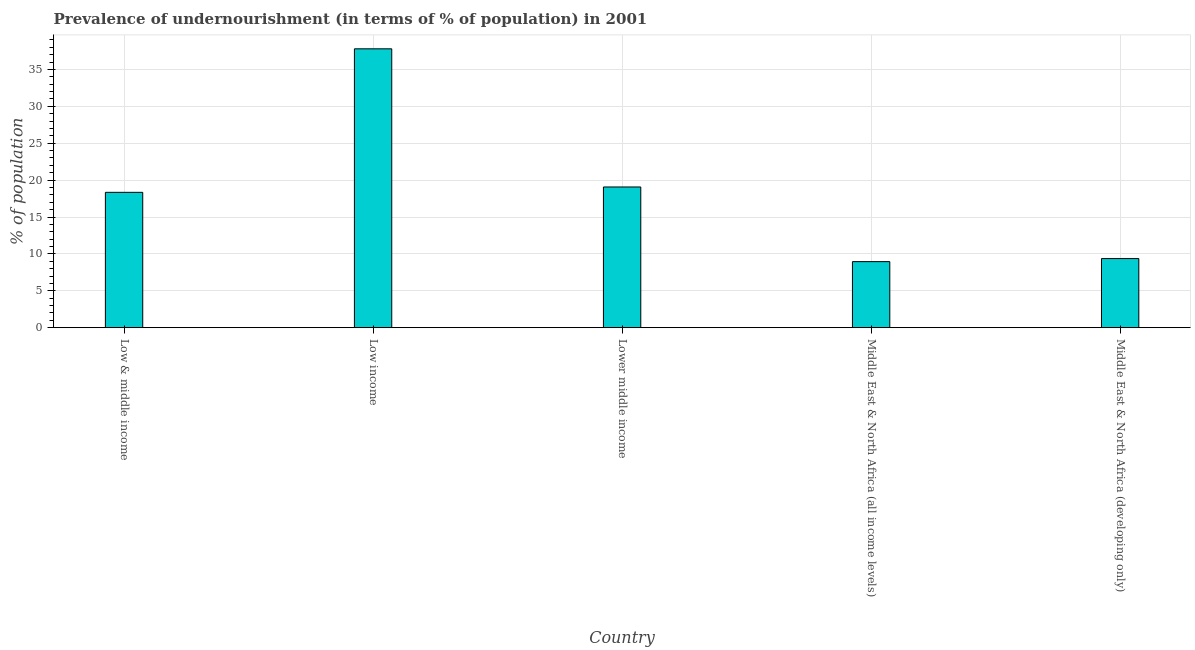Does the graph contain grids?
Provide a short and direct response. Yes. What is the title of the graph?
Offer a very short reply. Prevalence of undernourishment (in terms of % of population) in 2001. What is the label or title of the Y-axis?
Make the answer very short. % of population. What is the percentage of undernourished population in Low & middle income?
Your response must be concise. 18.35. Across all countries, what is the maximum percentage of undernourished population?
Ensure brevity in your answer.  37.8. Across all countries, what is the minimum percentage of undernourished population?
Provide a succinct answer. 8.95. In which country was the percentage of undernourished population minimum?
Your response must be concise. Middle East & North Africa (all income levels). What is the sum of the percentage of undernourished population?
Give a very brief answer. 93.54. What is the difference between the percentage of undernourished population in Low & middle income and Middle East & North Africa (all income levels)?
Your answer should be very brief. 9.39. What is the average percentage of undernourished population per country?
Your answer should be compact. 18.71. What is the median percentage of undernourished population?
Ensure brevity in your answer.  18.35. What is the ratio of the percentage of undernourished population in Low & middle income to that in Lower middle income?
Your answer should be compact. 0.96. Is the percentage of undernourished population in Low & middle income less than that in Middle East & North Africa (developing only)?
Provide a short and direct response. No. Is the difference between the percentage of undernourished population in Low & middle income and Middle East & North Africa (all income levels) greater than the difference between any two countries?
Provide a short and direct response. No. What is the difference between the highest and the second highest percentage of undernourished population?
Offer a very short reply. 18.73. Is the sum of the percentage of undernourished population in Lower middle income and Middle East & North Africa (all income levels) greater than the maximum percentage of undernourished population across all countries?
Your answer should be compact. No. What is the difference between the highest and the lowest percentage of undernourished population?
Provide a succinct answer. 28.85. How many bars are there?
Your answer should be very brief. 5. Are all the bars in the graph horizontal?
Your answer should be compact. No. What is the difference between two consecutive major ticks on the Y-axis?
Keep it short and to the point. 5. What is the % of population in Low & middle income?
Offer a terse response. 18.35. What is the % of population in Low income?
Your response must be concise. 37.8. What is the % of population in Lower middle income?
Offer a very short reply. 19.07. What is the % of population of Middle East & North Africa (all income levels)?
Keep it short and to the point. 8.95. What is the % of population of Middle East & North Africa (developing only)?
Keep it short and to the point. 9.37. What is the difference between the % of population in Low & middle income and Low income?
Give a very brief answer. -19.45. What is the difference between the % of population in Low & middle income and Lower middle income?
Your response must be concise. -0.73. What is the difference between the % of population in Low & middle income and Middle East & North Africa (all income levels)?
Your response must be concise. 9.4. What is the difference between the % of population in Low & middle income and Middle East & North Africa (developing only)?
Make the answer very short. 8.98. What is the difference between the % of population in Low income and Lower middle income?
Offer a very short reply. 18.73. What is the difference between the % of population in Low income and Middle East & North Africa (all income levels)?
Keep it short and to the point. 28.85. What is the difference between the % of population in Low income and Middle East & North Africa (developing only)?
Provide a succinct answer. 28.43. What is the difference between the % of population in Lower middle income and Middle East & North Africa (all income levels)?
Offer a very short reply. 10.12. What is the difference between the % of population in Lower middle income and Middle East & North Africa (developing only)?
Offer a very short reply. 9.7. What is the difference between the % of population in Middle East & North Africa (all income levels) and Middle East & North Africa (developing only)?
Ensure brevity in your answer.  -0.42. What is the ratio of the % of population in Low & middle income to that in Low income?
Your response must be concise. 0.48. What is the ratio of the % of population in Low & middle income to that in Lower middle income?
Ensure brevity in your answer.  0.96. What is the ratio of the % of population in Low & middle income to that in Middle East & North Africa (all income levels)?
Your response must be concise. 2.05. What is the ratio of the % of population in Low & middle income to that in Middle East & North Africa (developing only)?
Offer a very short reply. 1.96. What is the ratio of the % of population in Low income to that in Lower middle income?
Offer a terse response. 1.98. What is the ratio of the % of population in Low income to that in Middle East & North Africa (all income levels)?
Ensure brevity in your answer.  4.22. What is the ratio of the % of population in Low income to that in Middle East & North Africa (developing only)?
Keep it short and to the point. 4.04. What is the ratio of the % of population in Lower middle income to that in Middle East & North Africa (all income levels)?
Provide a short and direct response. 2.13. What is the ratio of the % of population in Lower middle income to that in Middle East & North Africa (developing only)?
Make the answer very short. 2.04. What is the ratio of the % of population in Middle East & North Africa (all income levels) to that in Middle East & North Africa (developing only)?
Your answer should be very brief. 0.96. 